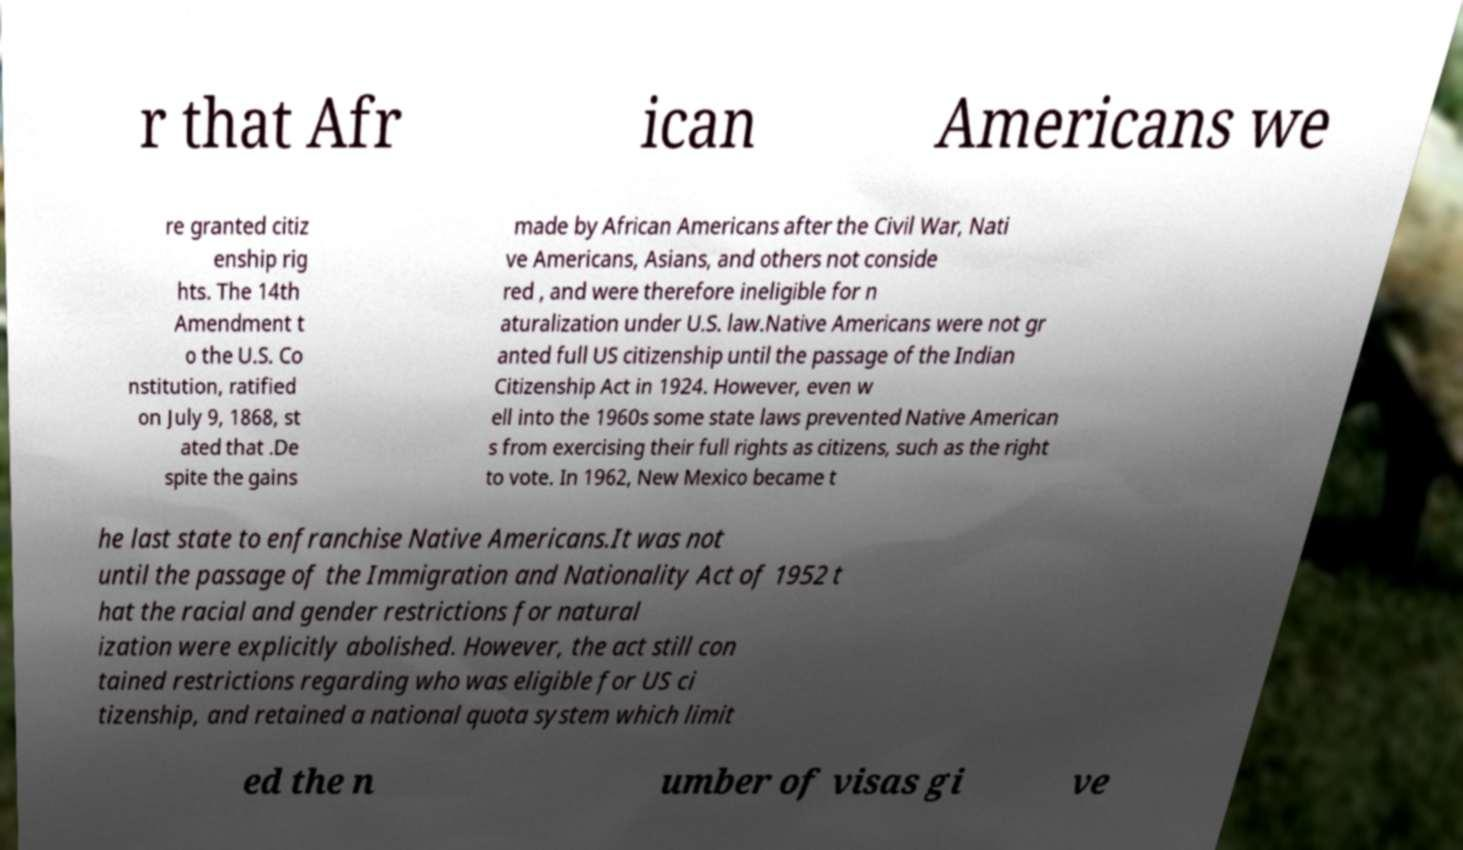For documentation purposes, I need the text within this image transcribed. Could you provide that? r that Afr ican Americans we re granted citiz enship rig hts. The 14th Amendment t o the U.S. Co nstitution, ratified on July 9, 1868, st ated that .De spite the gains made by African Americans after the Civil War, Nati ve Americans, Asians, and others not conside red , and were therefore ineligible for n aturalization under U.S. law.Native Americans were not gr anted full US citizenship until the passage of the Indian Citizenship Act in 1924. However, even w ell into the 1960s some state laws prevented Native American s from exercising their full rights as citizens, such as the right to vote. In 1962, New Mexico became t he last state to enfranchise Native Americans.It was not until the passage of the Immigration and Nationality Act of 1952 t hat the racial and gender restrictions for natural ization were explicitly abolished. However, the act still con tained restrictions regarding who was eligible for US ci tizenship, and retained a national quota system which limit ed the n umber of visas gi ve 